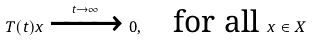Convert formula to latex. <formula><loc_0><loc_0><loc_500><loc_500>T ( t ) x \xrightarrow { t \rightarrow \infty } 0 , \quad \text {for all} \ x \in X</formula> 